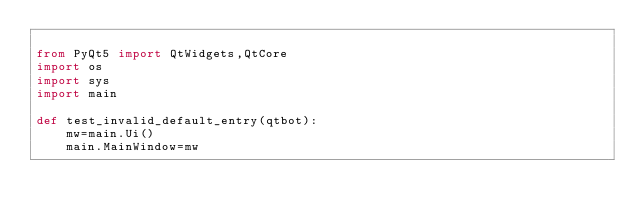Convert code to text. <code><loc_0><loc_0><loc_500><loc_500><_Python_>
from PyQt5 import QtWidgets,QtCore
import os
import sys
import main

def test_invalid_default_entry(qtbot):
    mw=main.Ui()
    main.MainWindow=mw
    
    
    
</code> 